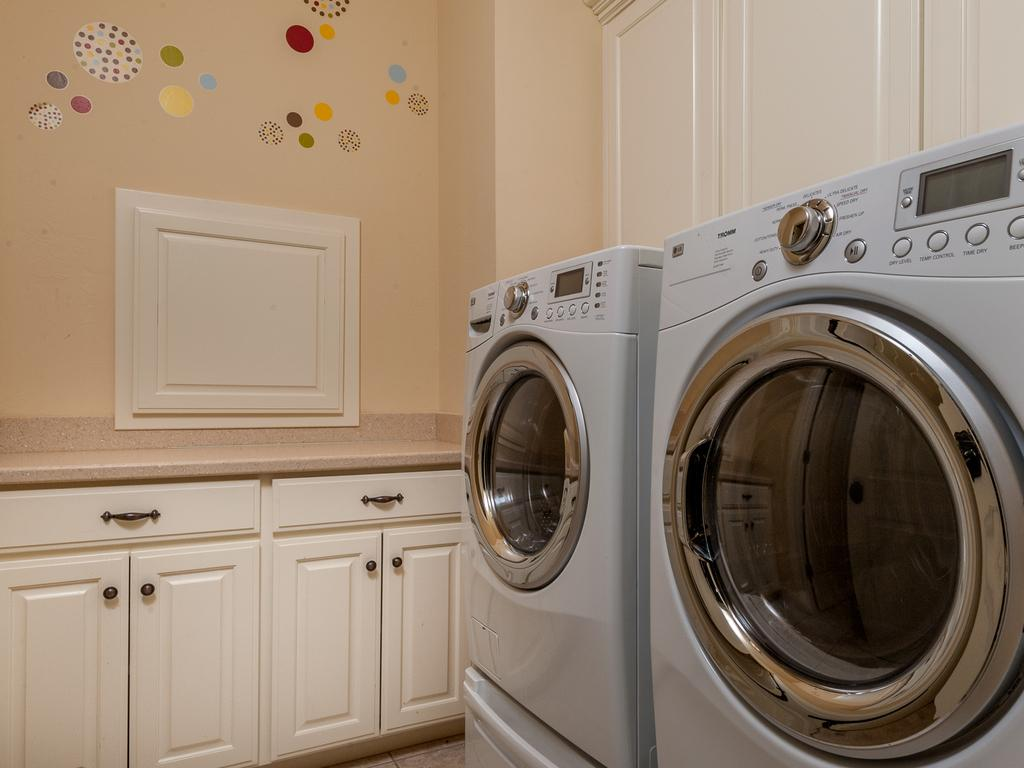How many washing machines are visible in the image? There are two washing machines in the image. What can be seen in the background of the image? There is a platform with cupboards in the background. What is the appearance of the wall in the background? The wall in the background has designs. What type of waves can be seen in the image? There are no waves present in the image. 